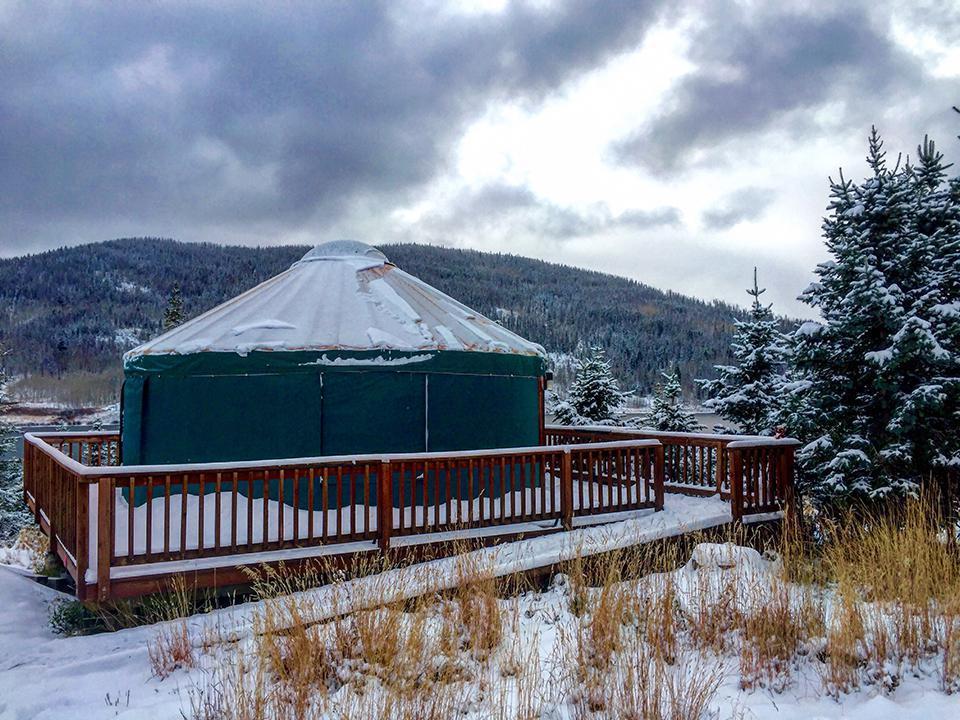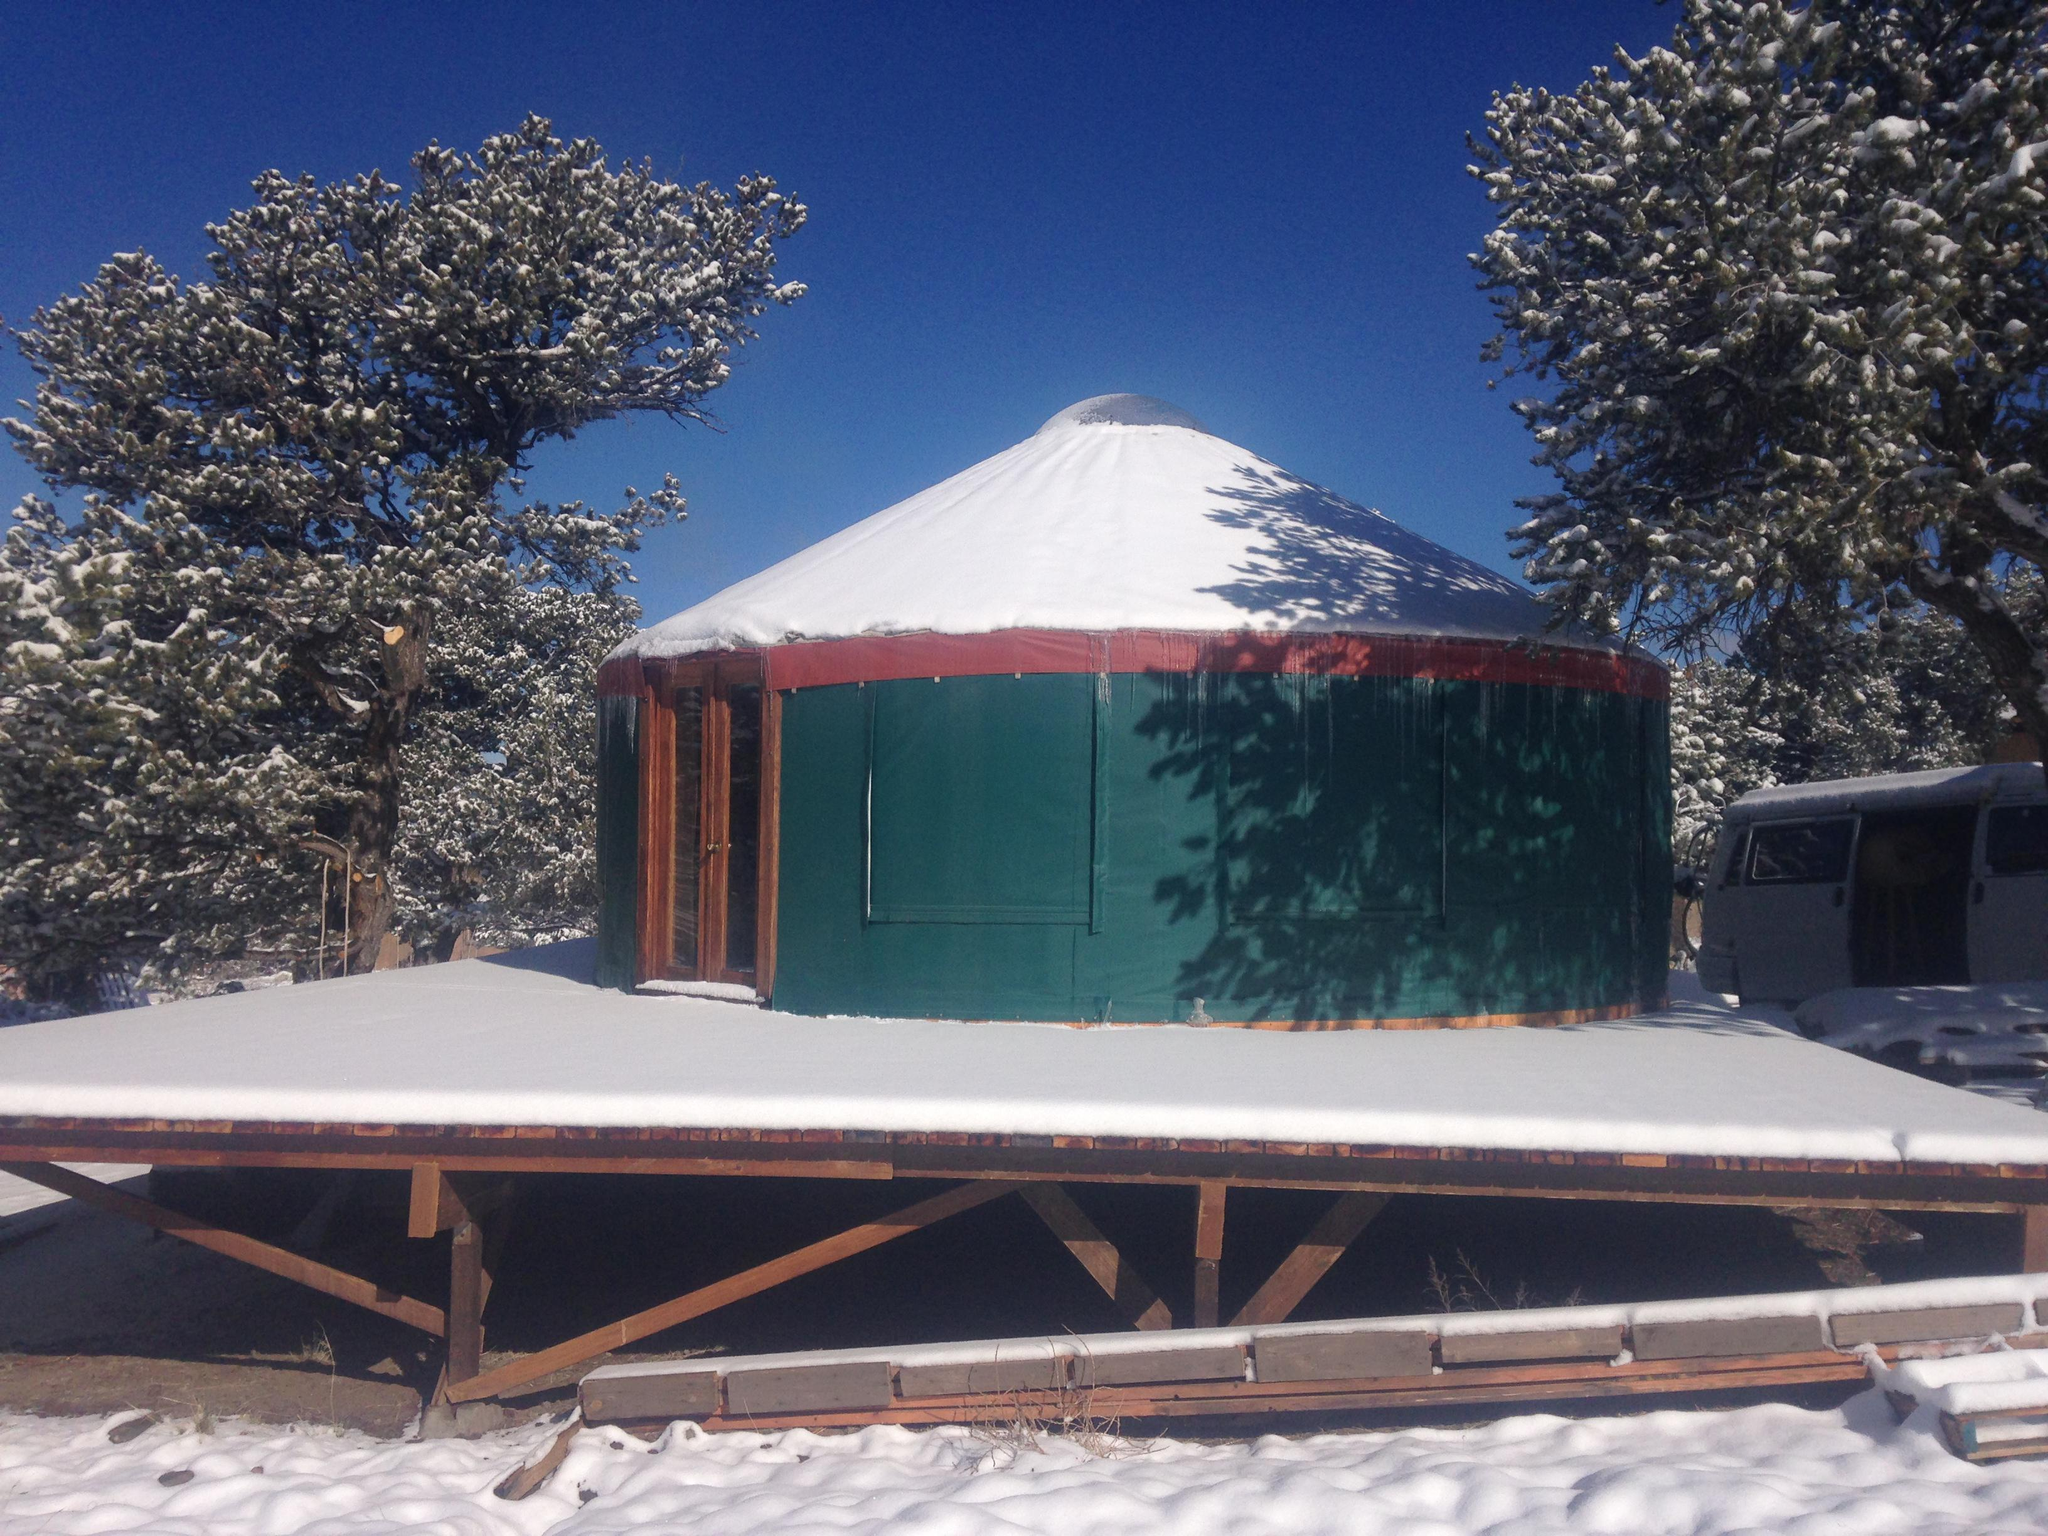The first image is the image on the left, the second image is the image on the right. For the images displayed, is the sentence "there is no fence around the yurt in the image on the right" factually correct? Answer yes or no. Yes. The first image is the image on the left, the second image is the image on the right. For the images shown, is this caption "Two green round houses have white roofs and sit on flat wooden platforms." true? Answer yes or no. Yes. 